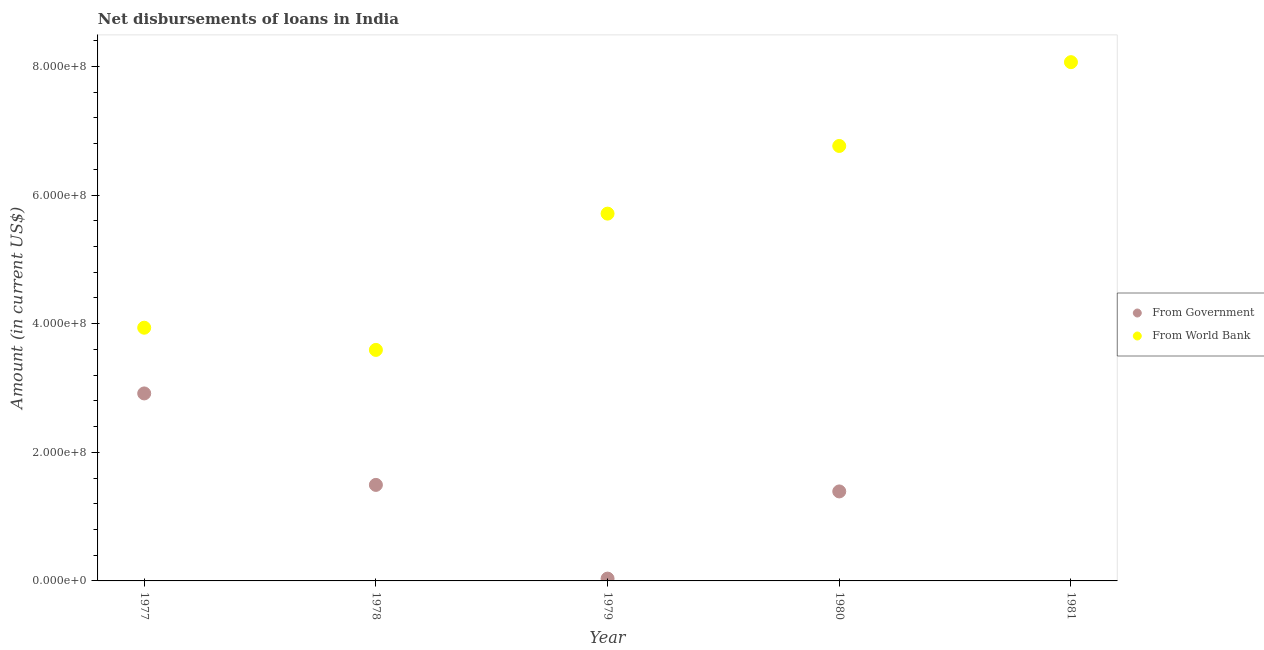How many different coloured dotlines are there?
Your response must be concise. 2. What is the net disbursements of loan from world bank in 1979?
Provide a short and direct response. 5.71e+08. Across all years, what is the maximum net disbursements of loan from government?
Ensure brevity in your answer.  2.92e+08. Across all years, what is the minimum net disbursements of loan from government?
Give a very brief answer. 0. In which year was the net disbursements of loan from world bank maximum?
Your response must be concise. 1981. What is the total net disbursements of loan from world bank in the graph?
Offer a very short reply. 2.81e+09. What is the difference between the net disbursements of loan from world bank in 1977 and that in 1980?
Ensure brevity in your answer.  -2.83e+08. What is the difference between the net disbursements of loan from world bank in 1981 and the net disbursements of loan from government in 1977?
Provide a short and direct response. 5.15e+08. What is the average net disbursements of loan from world bank per year?
Provide a succinct answer. 5.61e+08. In the year 1980, what is the difference between the net disbursements of loan from government and net disbursements of loan from world bank?
Make the answer very short. -5.37e+08. In how many years, is the net disbursements of loan from government greater than 560000000 US$?
Ensure brevity in your answer.  0. What is the ratio of the net disbursements of loan from government in 1978 to that in 1980?
Ensure brevity in your answer.  1.07. Is the net disbursements of loan from world bank in 1978 less than that in 1981?
Keep it short and to the point. Yes. What is the difference between the highest and the second highest net disbursements of loan from world bank?
Provide a succinct answer. 1.30e+08. What is the difference between the highest and the lowest net disbursements of loan from world bank?
Your response must be concise. 4.47e+08. In how many years, is the net disbursements of loan from government greater than the average net disbursements of loan from government taken over all years?
Provide a short and direct response. 3. Does the net disbursements of loan from government monotonically increase over the years?
Make the answer very short. No. Is the net disbursements of loan from world bank strictly greater than the net disbursements of loan from government over the years?
Your response must be concise. Yes. Is the net disbursements of loan from world bank strictly less than the net disbursements of loan from government over the years?
Make the answer very short. No. Does the graph contain any zero values?
Make the answer very short. Yes. Does the graph contain grids?
Your response must be concise. No. Where does the legend appear in the graph?
Give a very brief answer. Center right. What is the title of the graph?
Offer a terse response. Net disbursements of loans in India. Does "Female" appear as one of the legend labels in the graph?
Your answer should be compact. No. What is the label or title of the X-axis?
Your response must be concise. Year. What is the Amount (in current US$) of From Government in 1977?
Give a very brief answer. 2.92e+08. What is the Amount (in current US$) in From World Bank in 1977?
Keep it short and to the point. 3.94e+08. What is the Amount (in current US$) in From Government in 1978?
Offer a terse response. 1.49e+08. What is the Amount (in current US$) of From World Bank in 1978?
Keep it short and to the point. 3.59e+08. What is the Amount (in current US$) of From Government in 1979?
Make the answer very short. 3.59e+06. What is the Amount (in current US$) in From World Bank in 1979?
Provide a short and direct response. 5.71e+08. What is the Amount (in current US$) in From Government in 1980?
Your answer should be compact. 1.39e+08. What is the Amount (in current US$) of From World Bank in 1980?
Make the answer very short. 6.76e+08. What is the Amount (in current US$) in From Government in 1981?
Offer a terse response. 0. What is the Amount (in current US$) in From World Bank in 1981?
Your response must be concise. 8.07e+08. Across all years, what is the maximum Amount (in current US$) of From Government?
Keep it short and to the point. 2.92e+08. Across all years, what is the maximum Amount (in current US$) of From World Bank?
Make the answer very short. 8.07e+08. Across all years, what is the minimum Amount (in current US$) of From Government?
Offer a very short reply. 0. Across all years, what is the minimum Amount (in current US$) of From World Bank?
Your response must be concise. 3.59e+08. What is the total Amount (in current US$) in From Government in the graph?
Provide a short and direct response. 5.84e+08. What is the total Amount (in current US$) of From World Bank in the graph?
Provide a short and direct response. 2.81e+09. What is the difference between the Amount (in current US$) in From Government in 1977 and that in 1978?
Ensure brevity in your answer.  1.42e+08. What is the difference between the Amount (in current US$) of From World Bank in 1977 and that in 1978?
Offer a very short reply. 3.45e+07. What is the difference between the Amount (in current US$) in From Government in 1977 and that in 1979?
Your response must be concise. 2.88e+08. What is the difference between the Amount (in current US$) of From World Bank in 1977 and that in 1979?
Your response must be concise. -1.77e+08. What is the difference between the Amount (in current US$) in From Government in 1977 and that in 1980?
Offer a very short reply. 1.52e+08. What is the difference between the Amount (in current US$) in From World Bank in 1977 and that in 1980?
Give a very brief answer. -2.83e+08. What is the difference between the Amount (in current US$) of From World Bank in 1977 and that in 1981?
Your response must be concise. -4.13e+08. What is the difference between the Amount (in current US$) in From Government in 1978 and that in 1979?
Make the answer very short. 1.46e+08. What is the difference between the Amount (in current US$) of From World Bank in 1978 and that in 1979?
Give a very brief answer. -2.12e+08. What is the difference between the Amount (in current US$) of From Government in 1978 and that in 1980?
Keep it short and to the point. 1.02e+07. What is the difference between the Amount (in current US$) in From World Bank in 1978 and that in 1980?
Provide a succinct answer. -3.17e+08. What is the difference between the Amount (in current US$) in From World Bank in 1978 and that in 1981?
Ensure brevity in your answer.  -4.47e+08. What is the difference between the Amount (in current US$) of From Government in 1979 and that in 1980?
Your answer should be compact. -1.36e+08. What is the difference between the Amount (in current US$) in From World Bank in 1979 and that in 1980?
Provide a succinct answer. -1.05e+08. What is the difference between the Amount (in current US$) of From World Bank in 1979 and that in 1981?
Make the answer very short. -2.36e+08. What is the difference between the Amount (in current US$) in From World Bank in 1980 and that in 1981?
Offer a terse response. -1.30e+08. What is the difference between the Amount (in current US$) of From Government in 1977 and the Amount (in current US$) of From World Bank in 1978?
Your answer should be compact. -6.77e+07. What is the difference between the Amount (in current US$) in From Government in 1977 and the Amount (in current US$) in From World Bank in 1979?
Offer a very short reply. -2.80e+08. What is the difference between the Amount (in current US$) of From Government in 1977 and the Amount (in current US$) of From World Bank in 1980?
Your answer should be very brief. -3.85e+08. What is the difference between the Amount (in current US$) of From Government in 1977 and the Amount (in current US$) of From World Bank in 1981?
Give a very brief answer. -5.15e+08. What is the difference between the Amount (in current US$) in From Government in 1978 and the Amount (in current US$) in From World Bank in 1979?
Give a very brief answer. -4.22e+08. What is the difference between the Amount (in current US$) in From Government in 1978 and the Amount (in current US$) in From World Bank in 1980?
Keep it short and to the point. -5.27e+08. What is the difference between the Amount (in current US$) of From Government in 1978 and the Amount (in current US$) of From World Bank in 1981?
Your answer should be compact. -6.57e+08. What is the difference between the Amount (in current US$) of From Government in 1979 and the Amount (in current US$) of From World Bank in 1980?
Provide a succinct answer. -6.73e+08. What is the difference between the Amount (in current US$) of From Government in 1979 and the Amount (in current US$) of From World Bank in 1981?
Provide a succinct answer. -8.03e+08. What is the difference between the Amount (in current US$) in From Government in 1980 and the Amount (in current US$) in From World Bank in 1981?
Provide a short and direct response. -6.68e+08. What is the average Amount (in current US$) of From Government per year?
Your answer should be compact. 1.17e+08. What is the average Amount (in current US$) in From World Bank per year?
Offer a very short reply. 5.61e+08. In the year 1977, what is the difference between the Amount (in current US$) of From Government and Amount (in current US$) of From World Bank?
Give a very brief answer. -1.02e+08. In the year 1978, what is the difference between the Amount (in current US$) in From Government and Amount (in current US$) in From World Bank?
Give a very brief answer. -2.10e+08. In the year 1979, what is the difference between the Amount (in current US$) in From Government and Amount (in current US$) in From World Bank?
Keep it short and to the point. -5.68e+08. In the year 1980, what is the difference between the Amount (in current US$) in From Government and Amount (in current US$) in From World Bank?
Keep it short and to the point. -5.37e+08. What is the ratio of the Amount (in current US$) in From Government in 1977 to that in 1978?
Provide a short and direct response. 1.95. What is the ratio of the Amount (in current US$) of From World Bank in 1977 to that in 1978?
Make the answer very short. 1.1. What is the ratio of the Amount (in current US$) in From Government in 1977 to that in 1979?
Your answer should be compact. 81.23. What is the ratio of the Amount (in current US$) in From World Bank in 1977 to that in 1979?
Make the answer very short. 0.69. What is the ratio of the Amount (in current US$) in From Government in 1977 to that in 1980?
Provide a succinct answer. 2.1. What is the ratio of the Amount (in current US$) of From World Bank in 1977 to that in 1980?
Offer a very short reply. 0.58. What is the ratio of the Amount (in current US$) in From World Bank in 1977 to that in 1981?
Offer a very short reply. 0.49. What is the ratio of the Amount (in current US$) in From Government in 1978 to that in 1979?
Your answer should be very brief. 41.6. What is the ratio of the Amount (in current US$) of From World Bank in 1978 to that in 1979?
Offer a very short reply. 0.63. What is the ratio of the Amount (in current US$) in From Government in 1978 to that in 1980?
Offer a very short reply. 1.07. What is the ratio of the Amount (in current US$) in From World Bank in 1978 to that in 1980?
Provide a short and direct response. 0.53. What is the ratio of the Amount (in current US$) of From World Bank in 1978 to that in 1981?
Ensure brevity in your answer.  0.45. What is the ratio of the Amount (in current US$) in From Government in 1979 to that in 1980?
Keep it short and to the point. 0.03. What is the ratio of the Amount (in current US$) in From World Bank in 1979 to that in 1980?
Keep it short and to the point. 0.84. What is the ratio of the Amount (in current US$) of From World Bank in 1979 to that in 1981?
Offer a terse response. 0.71. What is the ratio of the Amount (in current US$) in From World Bank in 1980 to that in 1981?
Your answer should be very brief. 0.84. What is the difference between the highest and the second highest Amount (in current US$) in From Government?
Give a very brief answer. 1.42e+08. What is the difference between the highest and the second highest Amount (in current US$) in From World Bank?
Your answer should be very brief. 1.30e+08. What is the difference between the highest and the lowest Amount (in current US$) in From Government?
Give a very brief answer. 2.92e+08. What is the difference between the highest and the lowest Amount (in current US$) in From World Bank?
Your answer should be very brief. 4.47e+08. 